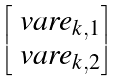<formula> <loc_0><loc_0><loc_500><loc_500>\begin{bmatrix} \ v a r e _ { k , 1 } \\ \ v a r e _ { k , 2 } \end{bmatrix}</formula> 